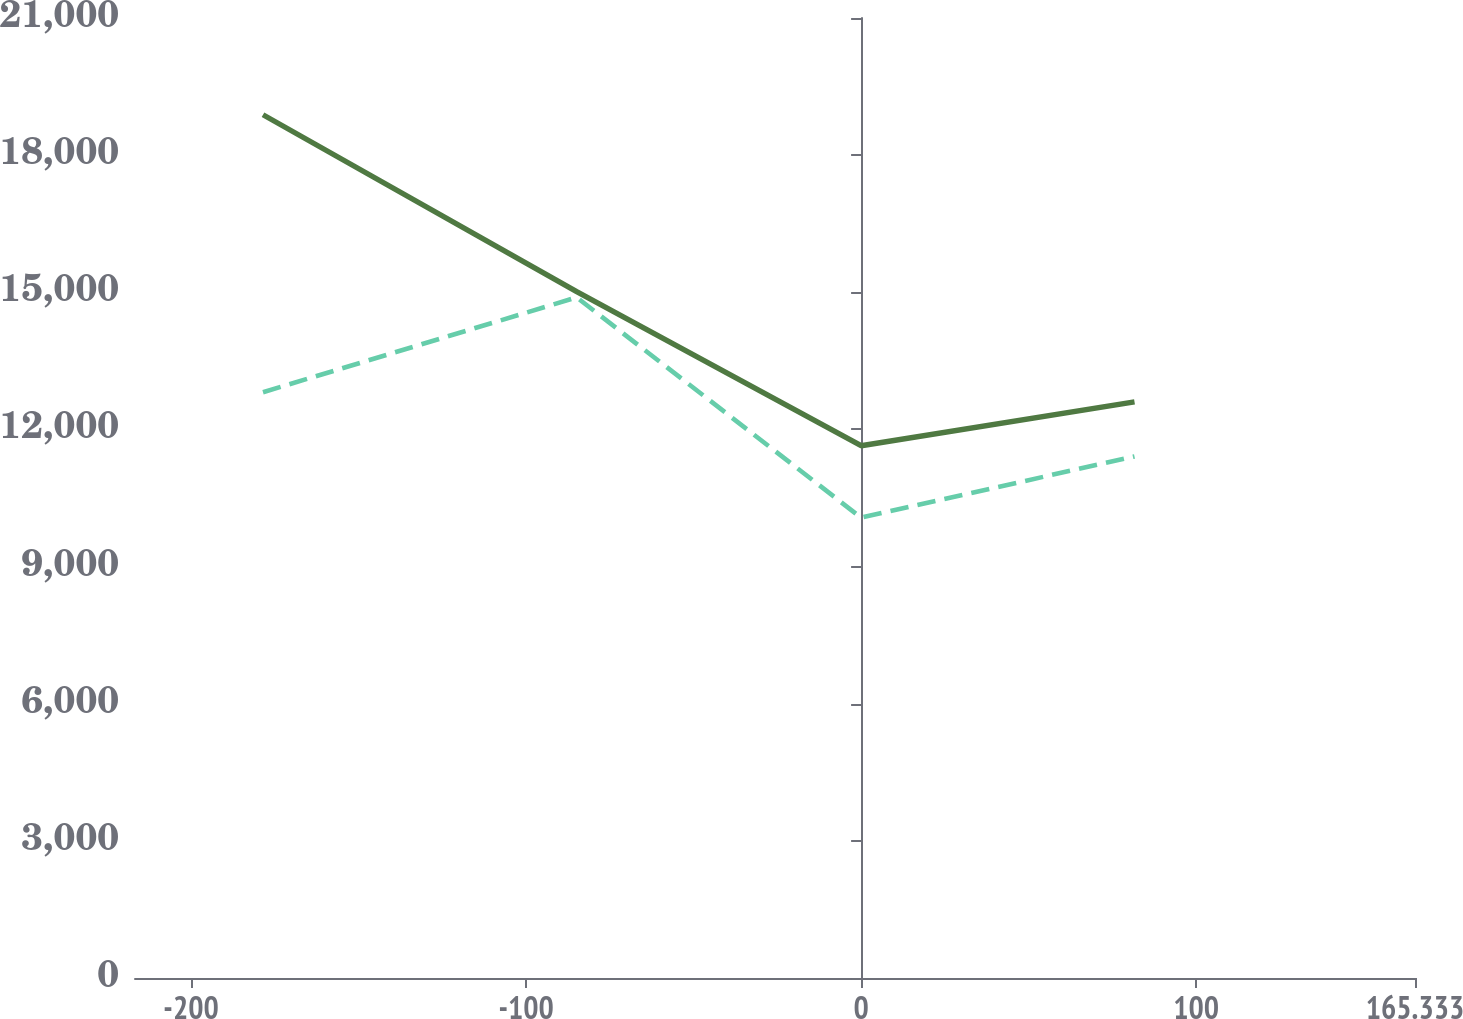<chart> <loc_0><loc_0><loc_500><loc_500><line_chart><ecel><fcel>At December 31, 2011<fcel>At December 31, 2012<nl><fcel>-178.53<fcel>18884<fcel>12813.7<nl><fcel>-84.9<fcel>15013.2<fcel>14888.7<nl><fcel>0<fcel>11643.7<fcel>10069.7<nl><fcel>81.61<fcel>12603.5<fcel>11410.1<nl><fcel>203.54<fcel>9347.04<fcel>10551.6<nl></chart> 